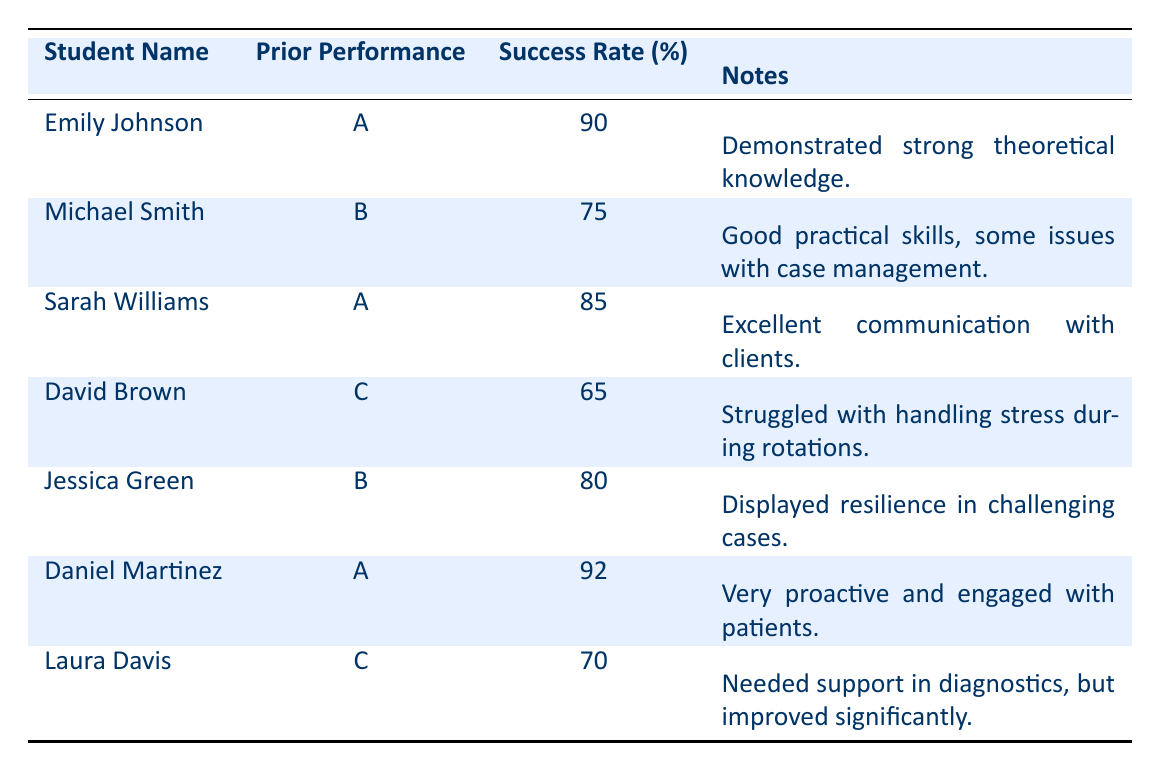What is the success rate of Emily Johnson? Emily Johnson's success rate is directly listed in the table under the 'Success Rate (%)' column. The value shown for her is 90.
Answer: 90 How many students achieved a success rate of 80% or higher? We look at the success rates of each student: Emily Johnson (90), Sarah Williams (85), Daniel Martinez (92), and Jessica Green (80). There are four students with success rates of 80% or higher.
Answer: 4 What are the success rates of students with a prior academic performance of 'C'? The success rates for students with a prior performance of 'C' are those of David Brown (65) and Laura Davis (70) listed in the table. They can be retrieved from the 'Success Rate (%)' column corresponding to students with prior performance 'C'.
Answer: 65, 70 Is it true that all students with an 'A' prior academic performance have success rates above 85%? We check the success rates of students with an 'A' prior performance: Emily Johnson (90), Sarah Williams (85), and Daniel Martinez (92). Since Sarah Williams has a success rate of 85%, not all are above 85%.
Answer: No What is the average success rate of students with a prior academic performance of 'B'? Students with a 'B' performance are Michael Smith (75) and Jessica Green (80). We calculate the average: (75 + 80) / 2 = 155 / 2 = 77.5. This gives us the average success rate for this group.
Answer: 77.5 Which student has the highest success rate, and what note is provided about them? By reviewing the success rates, Daniel Martinez has the highest success rate at 92%. The note provided states he is "Very proactive and engaged with patients."
Answer: Daniel Martinez, "Very proactive and engaged with patients." What issues did David Brown face during his clinical rotations? David Brown's entry in the notes column states he "Struggled with handling stress during rotations." This indicates the specific challenges he experienced.
Answer: Struggled with handling stress How much higher is the success rate of Daniel Martinez compared to that of Laura Davis? Daniel Martinez has a success rate of 92, while Laura Davis has a success rate of 70. The difference is calculated as 92 - 70 = 22, indicating Daniel’s success rate is 22% higher than Laura's.
Answer: 22 How many students achieved success rates below 70%? Only David Brown (65) and Laura Davis (70) are below a success rate of 70%. Laura's success rate is exactly 70%, so she is not included in the count for below 70%. The only student below this threshold is David Brown.
Answer: 1 